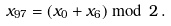Convert formula to latex. <formula><loc_0><loc_0><loc_500><loc_500>x _ { 9 7 } = ( x _ { 0 } + x _ { 6 } ) \bmod \, 2 \, .</formula> 